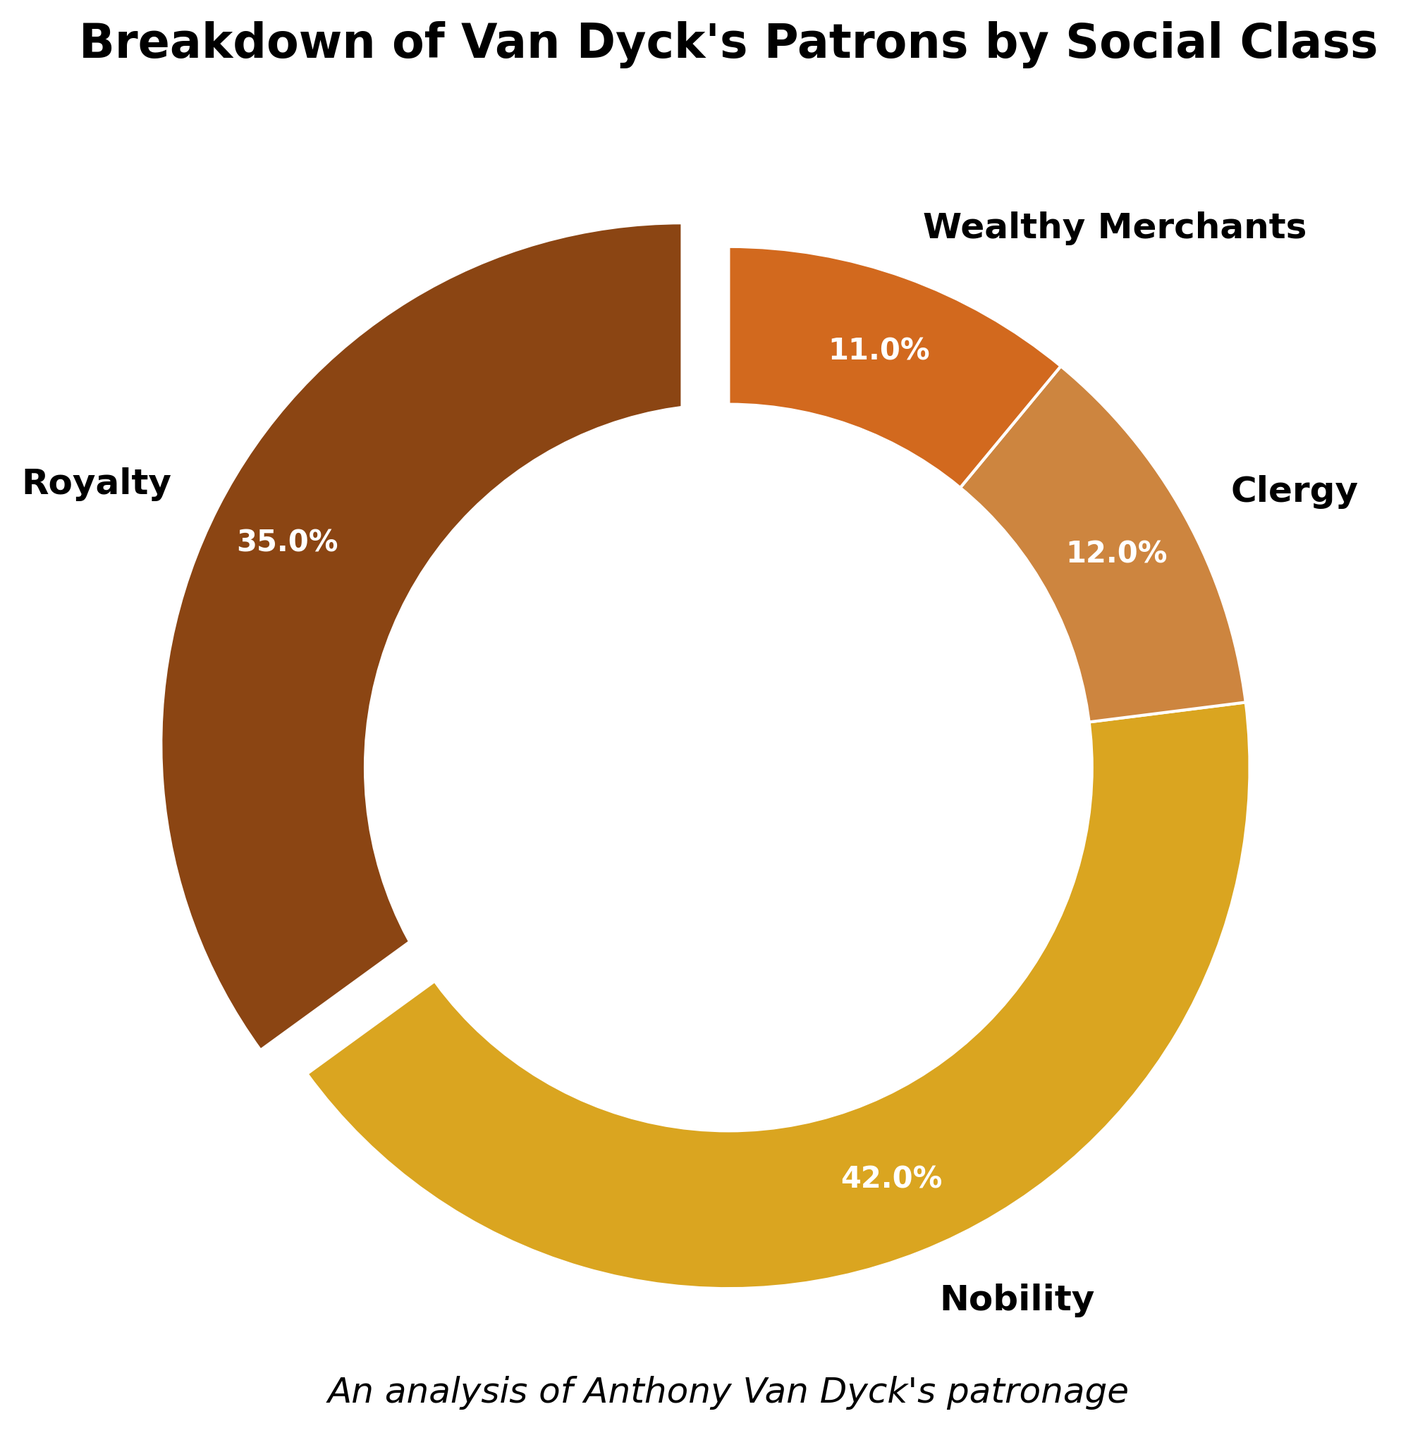What percentage of Van Dyck's patrons are from the nobility class? The segment labeled "Nobility" on the pie chart shows the corresponding percentage.
Answer: 42% Which social class has the smallest representation among Van Dyck's patrons? By observing the segments on the pie chart, the "Wealthy Merchants" section has the smallest size.
Answer: Wealthy Merchants How much larger is the percentage of Nobility compared to Clergy? Subtract the percentage of "Clergy" from the percentage of "Nobility" (42% - 12%).
Answer: 30% What two social classes together make up the majority of Van Dyck's patrons? Add the percentages of different classes and observe that "Nobility" (42%) and "Royalty" (35%) together sum up to 77%, which is more than 50%.
Answer: Nobility and Royalty What is the total percentage of patrons that are not from the nobility class? Add the percentages of Royalty (35%), Clergy (12%), and Wealthy Merchants (11%) and sum them up. (35% + 12% + 11% = 58%)
Answer: 58% What color represents the "Royalty" category in the chart? Identify the color segment labeled as "Royalty" in the pie chart.
Answer: A shade of brown What percentage of Van Dyck's patrons are from the Clergy and Wealthy Merchants combined? Add the percentages for both the "Clergy" and "Wealthy Merchants" (12% + 11%).
Answer: 23% Is there any social class that constitutes over half of Van Dyck's patrons? Check if any segment accounts for more than 50%. None of the segments exceed 50%.
Answer: No What is the percentage difference between the largest and the smallest patron group? Find the percentages for "Nobility" (42%) and "Wealthy Merchants" (11%) and subtract the latter from the former (42% - 11%).
Answer: 31% 